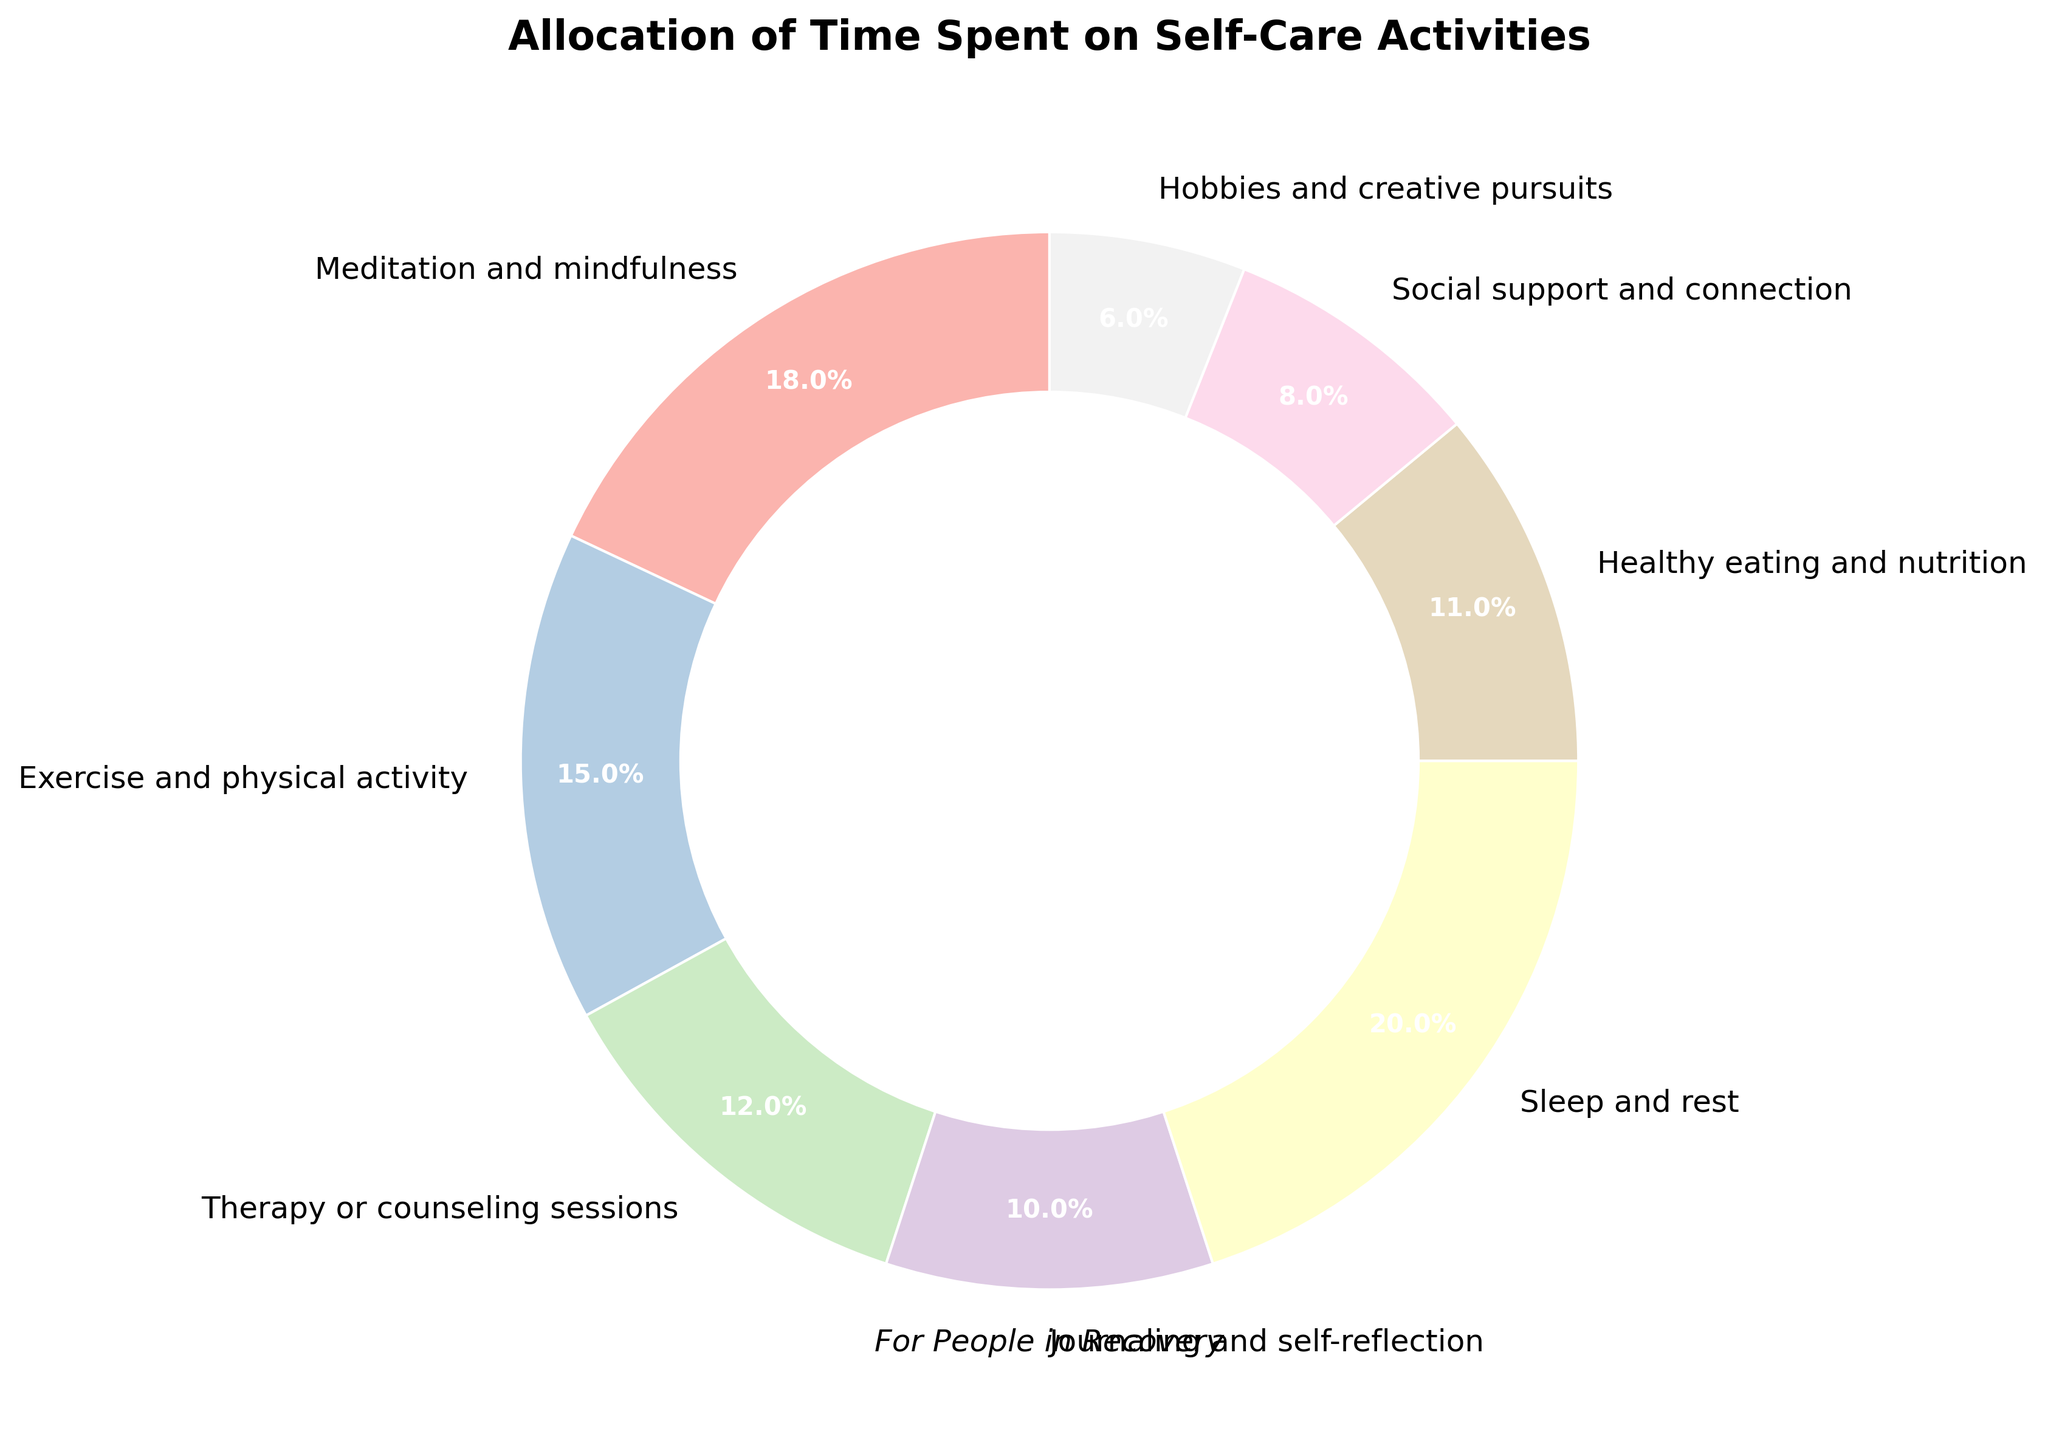What's the combined percentage of time spent on Meditation and mindfulness, Exercise and physical activity, and Healthy eating and nutrition? Sum the percentages for Meditation and mindfulness (18%), Exercise and physical activity (15%), and Healthy eating and nutrition (11%) to get the combined percentage. 18% + 15% + 11% = 44%
Answer: 44% Which activity occupies the largest portion of the pie? Identify the activity with the largest percentage on the pie chart. Sleep and rest has the highest percentage at 20%.
Answer: Sleep and rest What is the total percentage of time spent on activities related to mental health (Meditation and mindfulness, Therapy or counseling sessions, and Journaling and self-reflection)? Sum the percentages for Meditation and mindfulness (18%), Therapy or counseling sessions (12%), and Journaling and self-reflection (10%) to get the total percentage. 18% + 12% + 10% = 40%
Answer: 40% How does the percentage of time allocated to Hobbies and creative pursuits compare to that of Social support and connection? Compare the percentages: Hobbies and creative pursuits (6%) and Social support and connection (8%). Hobbies and creative pursuits is 2% less than Social support and connection.
Answer: 2% less What visual feature is used to provide a clear differentiation between the activities in the pie chart? Identify the graphical element that distinguishes the activities. Different colors are used to represent each activity, providing clear differentiation.
Answer: Different colors 